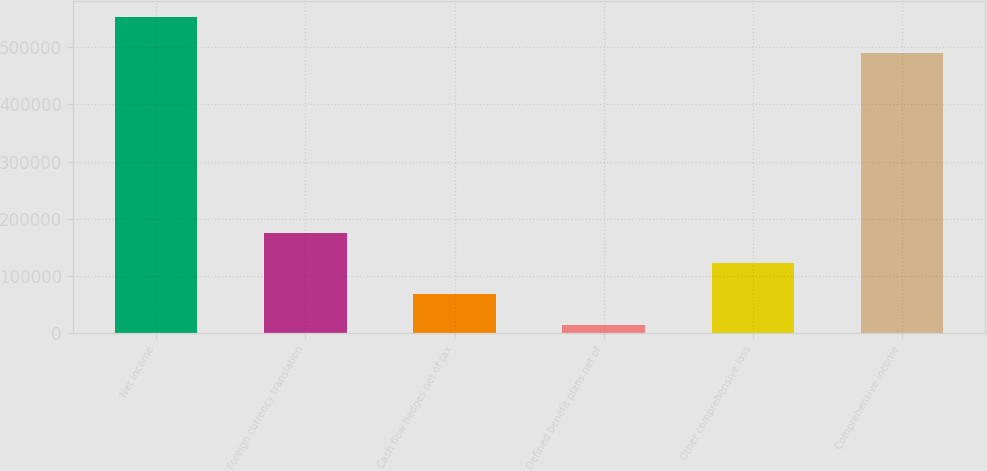Convert chart to OTSL. <chart><loc_0><loc_0><loc_500><loc_500><bar_chart><fcel>Net income<fcel>Foreign currency translation<fcel>Cash flow hedges net of tax<fcel>Defined benefit plans net of<fcel>Other comprehensive loss<fcel>Comprehensive income<nl><fcel>553084<fcel>175614<fcel>67765.3<fcel>13841<fcel>121690<fcel>489348<nl></chart> 